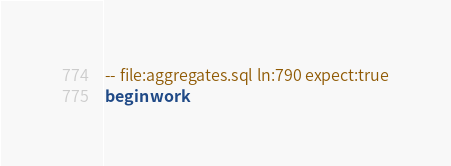Convert code to text. <code><loc_0><loc_0><loc_500><loc_500><_SQL_>-- file:aggregates.sql ln:790 expect:true
begin work
</code> 